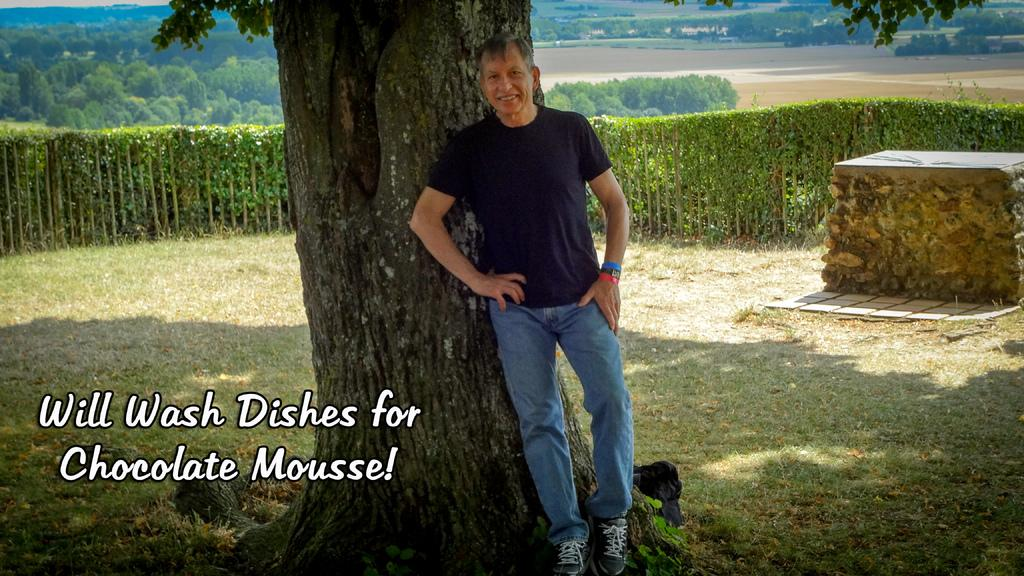What is the person in the image doing? The person is standing near a tree in the image. Is there any text present in the image? Yes, there is text on the bottom left side of the image. What type of natural elements can be seen on the right side of the image? There are rocks on the right side of the image. Where is the sofa located in the image? There is no sofa present in the image. 